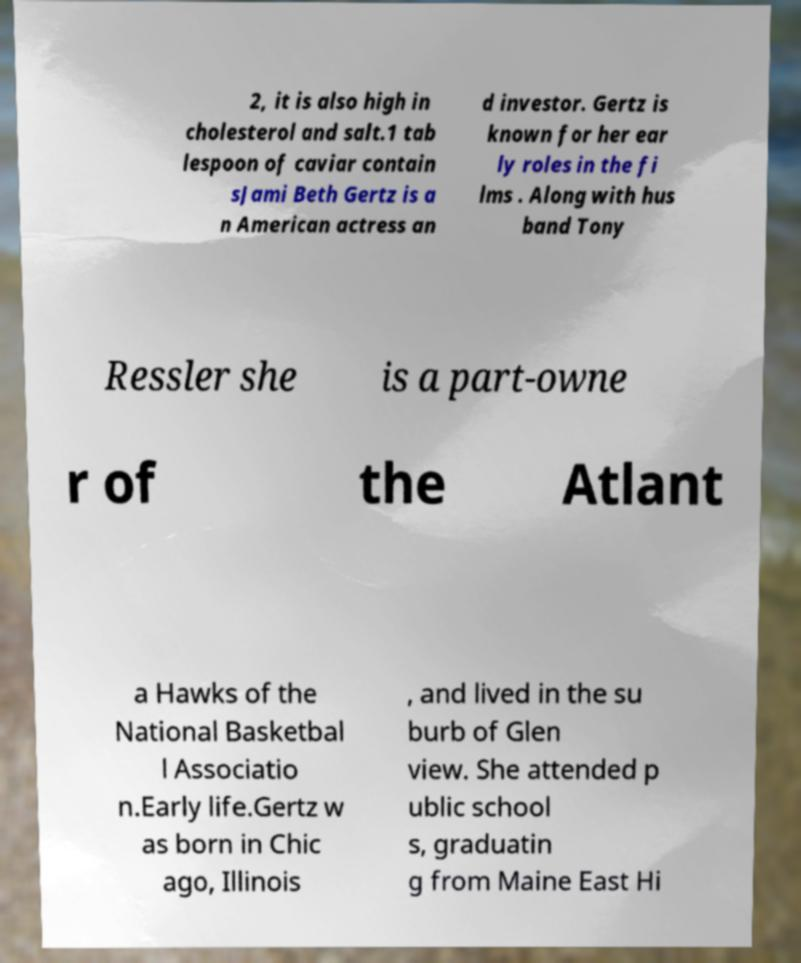Can you accurately transcribe the text from the provided image for me? 2, it is also high in cholesterol and salt.1 tab lespoon of caviar contain sJami Beth Gertz is a n American actress an d investor. Gertz is known for her ear ly roles in the fi lms . Along with hus band Tony Ressler she is a part-owne r of the Atlant a Hawks of the National Basketbal l Associatio n.Early life.Gertz w as born in Chic ago, Illinois , and lived in the su burb of Glen view. She attended p ublic school s, graduatin g from Maine East Hi 